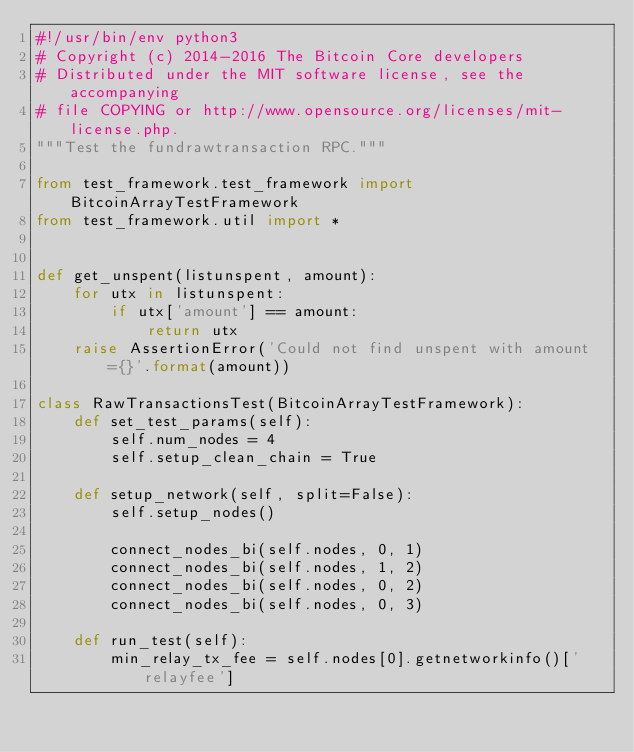Convert code to text. <code><loc_0><loc_0><loc_500><loc_500><_Python_>#!/usr/bin/env python3
# Copyright (c) 2014-2016 The Bitcoin Core developers
# Distributed under the MIT software license, see the accompanying
# file COPYING or http://www.opensource.org/licenses/mit-license.php.
"""Test the fundrawtransaction RPC."""

from test_framework.test_framework import BitcoinArrayTestFramework
from test_framework.util import *


def get_unspent(listunspent, amount):
    for utx in listunspent:
        if utx['amount'] == amount:
            return utx
    raise AssertionError('Could not find unspent with amount={}'.format(amount))

class RawTransactionsTest(BitcoinArrayTestFramework):
    def set_test_params(self):
        self.num_nodes = 4
        self.setup_clean_chain = True

    def setup_network(self, split=False):
        self.setup_nodes()

        connect_nodes_bi(self.nodes, 0, 1)
        connect_nodes_bi(self.nodes, 1, 2)
        connect_nodes_bi(self.nodes, 0, 2)
        connect_nodes_bi(self.nodes, 0, 3)

    def run_test(self):
        min_relay_tx_fee = self.nodes[0].getnetworkinfo()['relayfee']</code> 